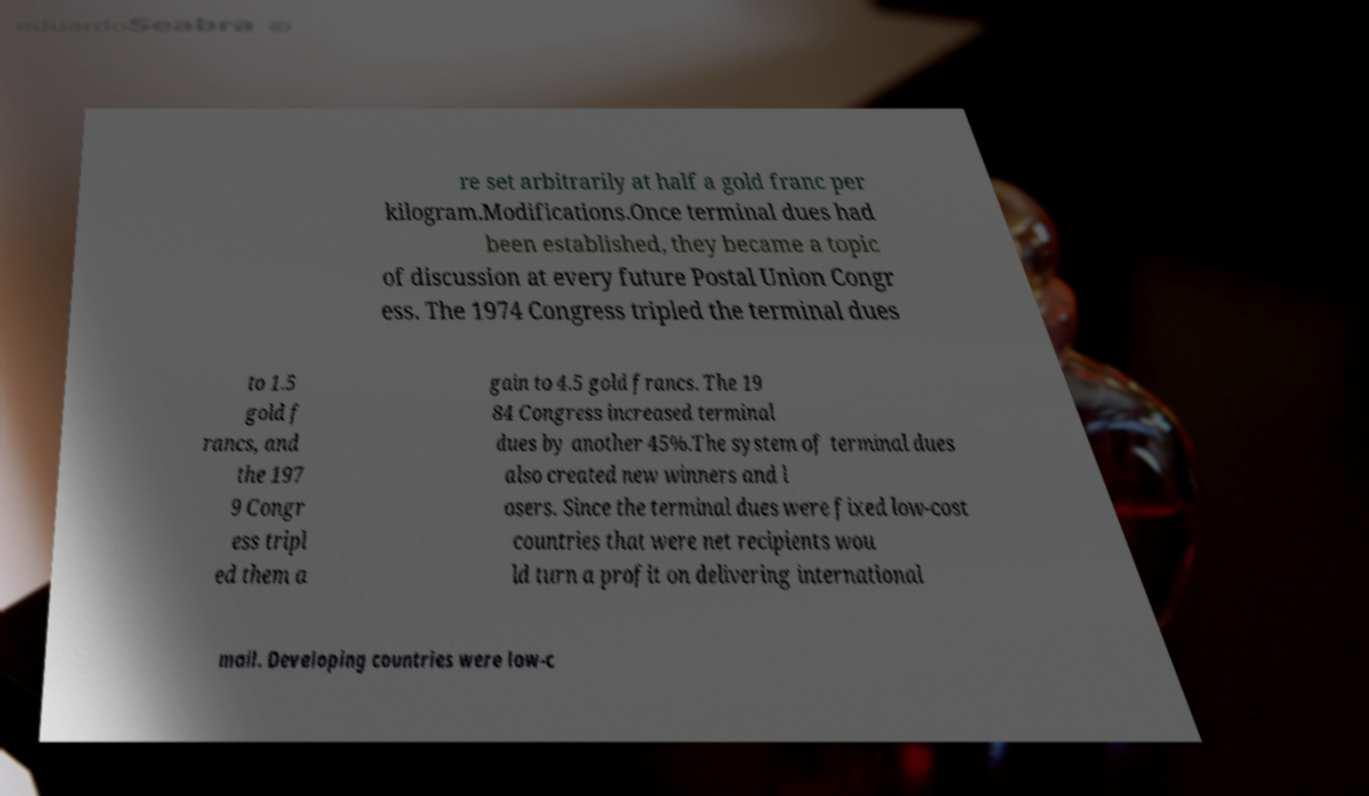Please identify and transcribe the text found in this image. re set arbitrarily at half a gold franc per kilogram.Modifications.Once terminal dues had been established, they became a topic of discussion at every future Postal Union Congr ess. The 1974 Congress tripled the terminal dues to 1.5 gold f rancs, and the 197 9 Congr ess tripl ed them a gain to 4.5 gold francs. The 19 84 Congress increased terminal dues by another 45%.The system of terminal dues also created new winners and l osers. Since the terminal dues were fixed low-cost countries that were net recipients wou ld turn a profit on delivering international mail. Developing countries were low-c 